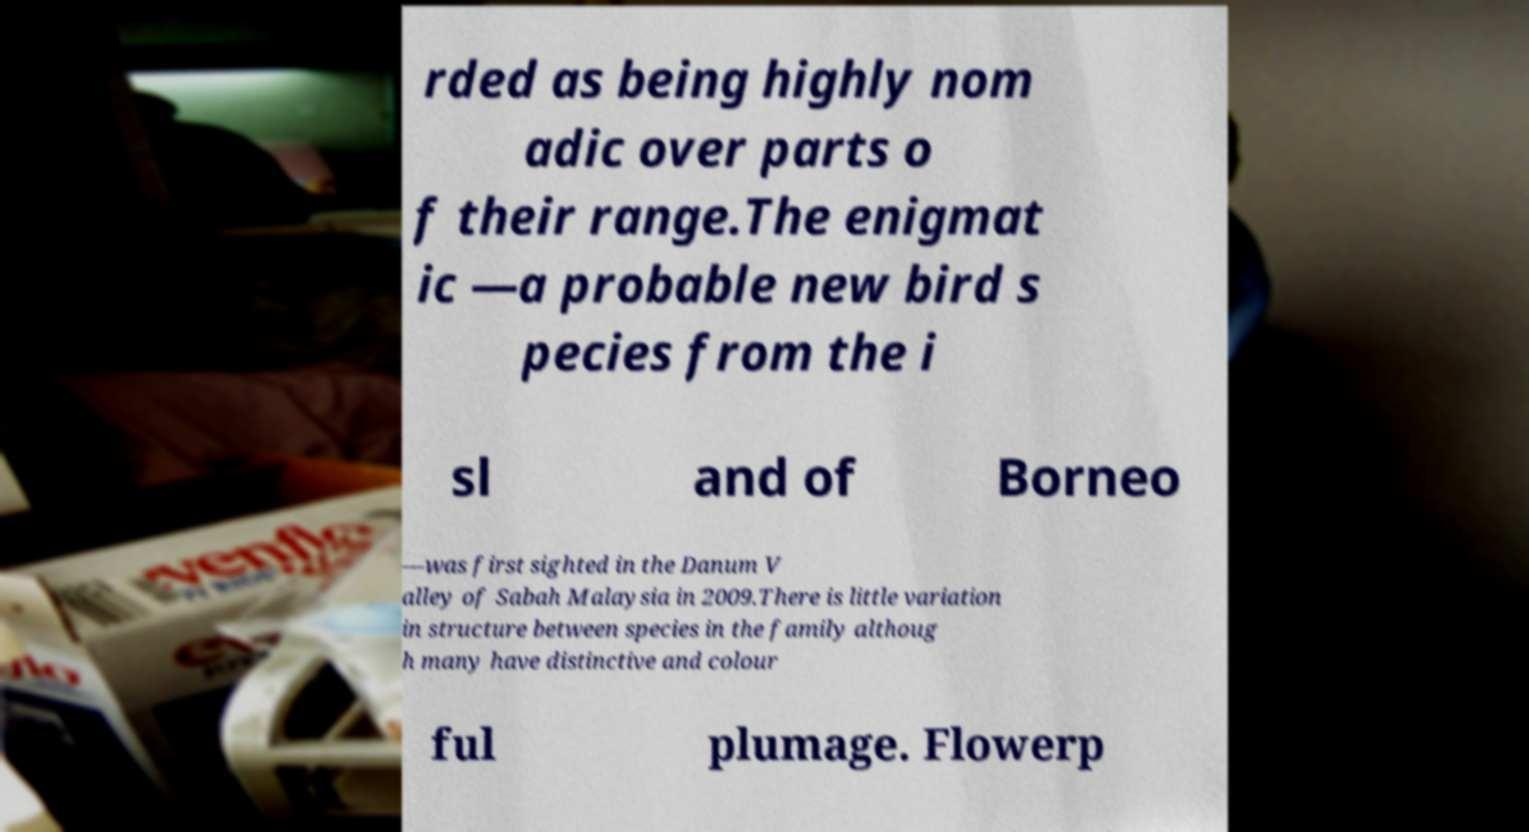For documentation purposes, I need the text within this image transcribed. Could you provide that? rded as being highly nom adic over parts o f their range.The enigmat ic —a probable new bird s pecies from the i sl and of Borneo —was first sighted in the Danum V alley of Sabah Malaysia in 2009.There is little variation in structure between species in the family althoug h many have distinctive and colour ful plumage. Flowerp 